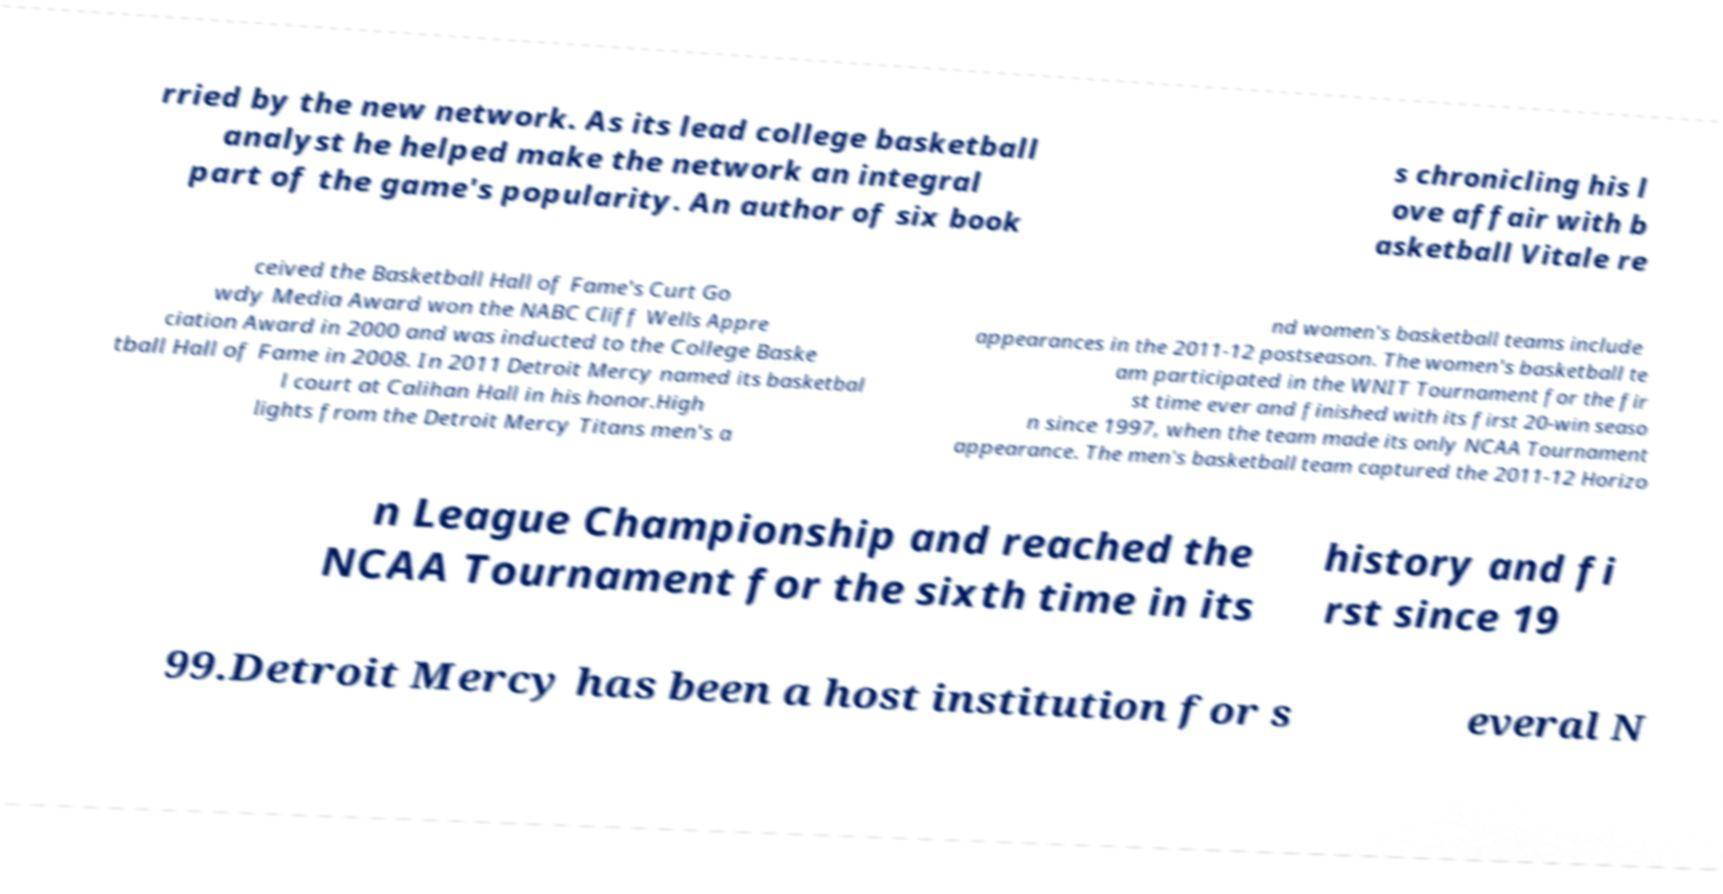Could you assist in decoding the text presented in this image and type it out clearly? rried by the new network. As its lead college basketball analyst he helped make the network an integral part of the game's popularity. An author of six book s chronicling his l ove affair with b asketball Vitale re ceived the Basketball Hall of Fame's Curt Go wdy Media Award won the NABC Cliff Wells Appre ciation Award in 2000 and was inducted to the College Baske tball Hall of Fame in 2008. In 2011 Detroit Mercy named its basketbal l court at Calihan Hall in his honor.High lights from the Detroit Mercy Titans men's a nd women's basketball teams include appearances in the 2011-12 postseason. The women's basketball te am participated in the WNIT Tournament for the fir st time ever and finished with its first 20-win seaso n since 1997, when the team made its only NCAA Tournament appearance. The men's basketball team captured the 2011-12 Horizo n League Championship and reached the NCAA Tournament for the sixth time in its history and fi rst since 19 99.Detroit Mercy has been a host institution for s everal N 